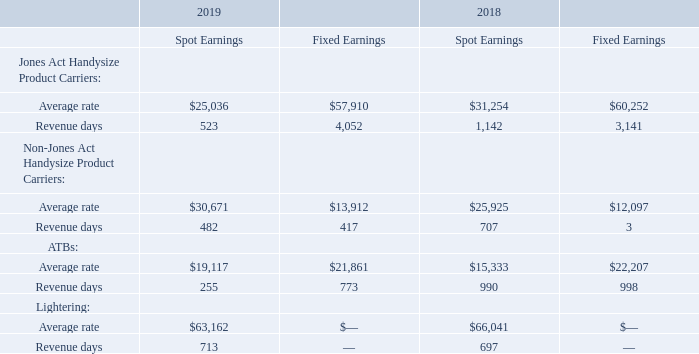The following table provides a breakdown of TCE rates achieved for the years ended December 31, 2019 and 2018 between spot and fixed earnings and the related revenue days.
During 2019, TCE revenues increased by $8,426, or 2.6%, to $335,133 from $326,707 in 2018. The increase primarily resulted from an increase in average daily rates earned by our fleet and decreased spot market exposure. The total number of revenue days decreased from 7,678 days in 2018 to 7,215 days in 2019. The decrease primarily resulted from three fewer vessels in operation during most of 2019 compared to 2018.
Vessel expenses remained stable at $134,618 in 2019 from $134,956 in 2018. Depreciation expense increased by $1,987 to $52,499 in 2019 from $50,512 in 2018. The increase was due to an increase in amortization of drydock costs and an increase in depreciation expense due to the Overseas Gulf Coast and Overseas Sun Coast, our two new vessels, which entered service at the beginning of the fourth quarter of 2019.
Two reflagged U.S. Flag Product Carriers participate in the U.S. Maritime Security Program, which ensures that privatelyowned, military-useful U.S. Flag vessels are available to the U.S. Department of Defense in the event of war or national emergency.
Each of the vessel-owning companies receives an annual subsidy, subject in each case to annual congressional appropriations, which is intended to offset the increased cost incurred by such vessels from operating under the U.S. Flag. Such subsidy was $5,000 for each vessel in 2019 and $5,000 on one vessel and $4,600 on one vessel in 2018.
Under the terms of the program, we expect to receive up to $5,000 annually for each vessel during 2020, and up to $5,200 for each vessel beginning in 2021. We do not receive a subsidy for any days for which either of the two vessels operate under a time charter to a U.S. government agency.
In June 2019, one of our lightering customers, PES, suffered an explosion and fire at its refinery in the Delaware Bay. The PES refinery complex, which consists of two refineries, has been shut down since the fire. Due to the expected reduction in lightering volumes, we redeployed one of our two lightering ATBs to the U.S. Gulf of Mexico for alternative employment.
In July 2019, PES filed a Chapter 11 bankruptcy petition. At December 31, 2019, we had outstanding receivables from PES of approximately $4,300. The ultimate recovery of these receivables is currently unknown. We established a loss provision of $4,300. We are working diligently to maximize our recovery.
In June 2018, one of our ATBs was berthed to the dock when a third-party ship transiting the channel hit our ATB, causing structural damage to the ATB and damage to the dock. The cost of repairs has been covered by existing insurance policies. We have filed a lawsuit against the third-party ship seeking recovery of our costs of repairs as well as our lost earnings from the ATB being off-hire for 46 repair days.
How much did TCE revenues increased during 2019 from 2018? $8,426. What led to the increase in TCE revenues? An increase in average daily rates earned by our fleet and decreased spot market exposure. What is the vessel expenses in 2019 and 2018 respectively? $134,618, $134,956. What is the change in Jones Act Handysize Product Carriers: Average rate in Spot Earnings between 2018 and 2019? 25,036-31,254
Answer: -6218. What is the change in Jones Act Handysize Product Carriers: Revenue days in Spot Earnings between 2018 and 2019? 523-1,142
Answer: -619. What is the change in Non-Jones Act Handysize Product Carriers: Average rate in Spot Earnings between 2018 and 2019? 30,671-25,925
Answer: 4746. 